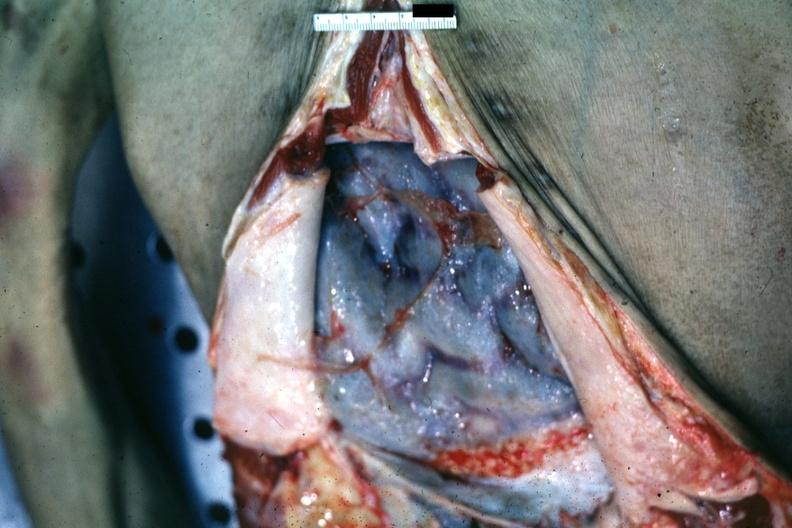what bound by neoplastic adhesions good but not the best ovarian papillary adenocarcinoma?
Answer the question using a single word or phrase. Opened abdomen with ischemic appearing intestines 